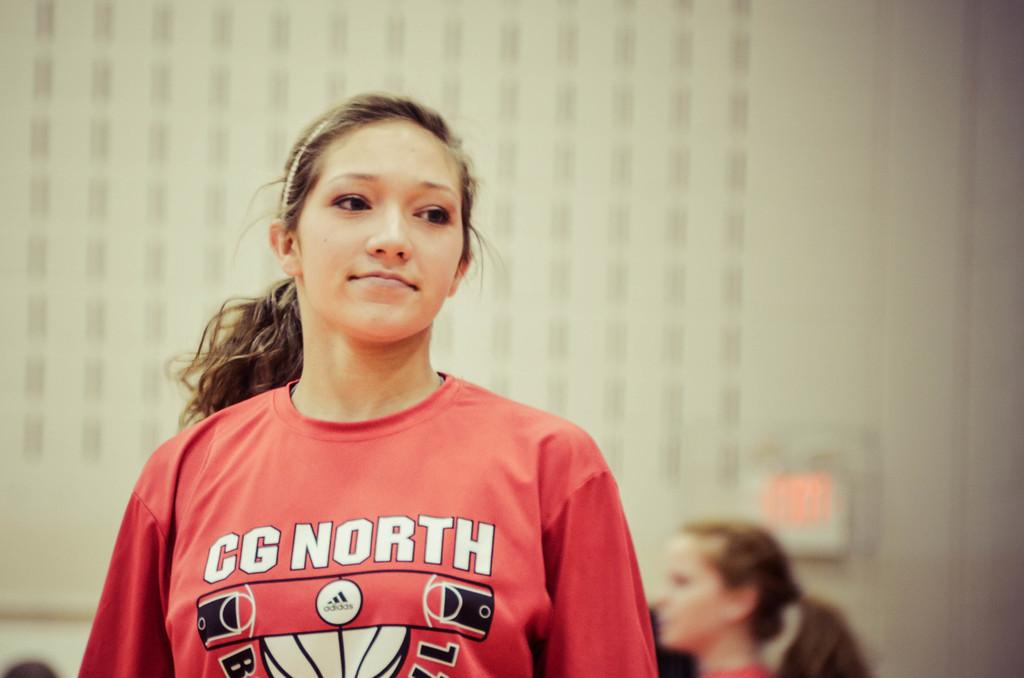What is the brand logo on the shirt?
Make the answer very short. Adidas. 